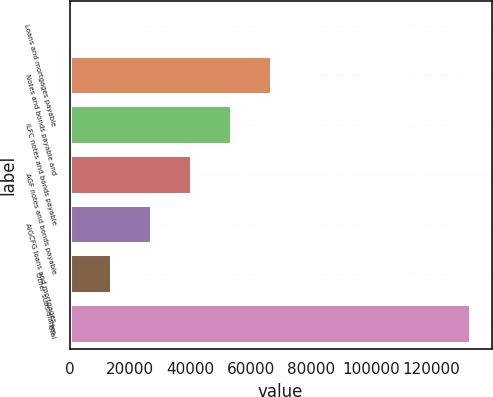<chart> <loc_0><loc_0><loc_500><loc_500><bar_chart><fcel>Loans and mortgages payable<fcel>Notes and bonds payable and<fcel>ILFC notes and bonds payable<fcel>AGF notes and bonds payable<fcel>AIGCFG loans and mortgages<fcel>Other subsidiaries<fcel>Total<nl><fcel>841<fcel>67063<fcel>53818.6<fcel>40574.2<fcel>27329.8<fcel>14085.4<fcel>133285<nl></chart> 